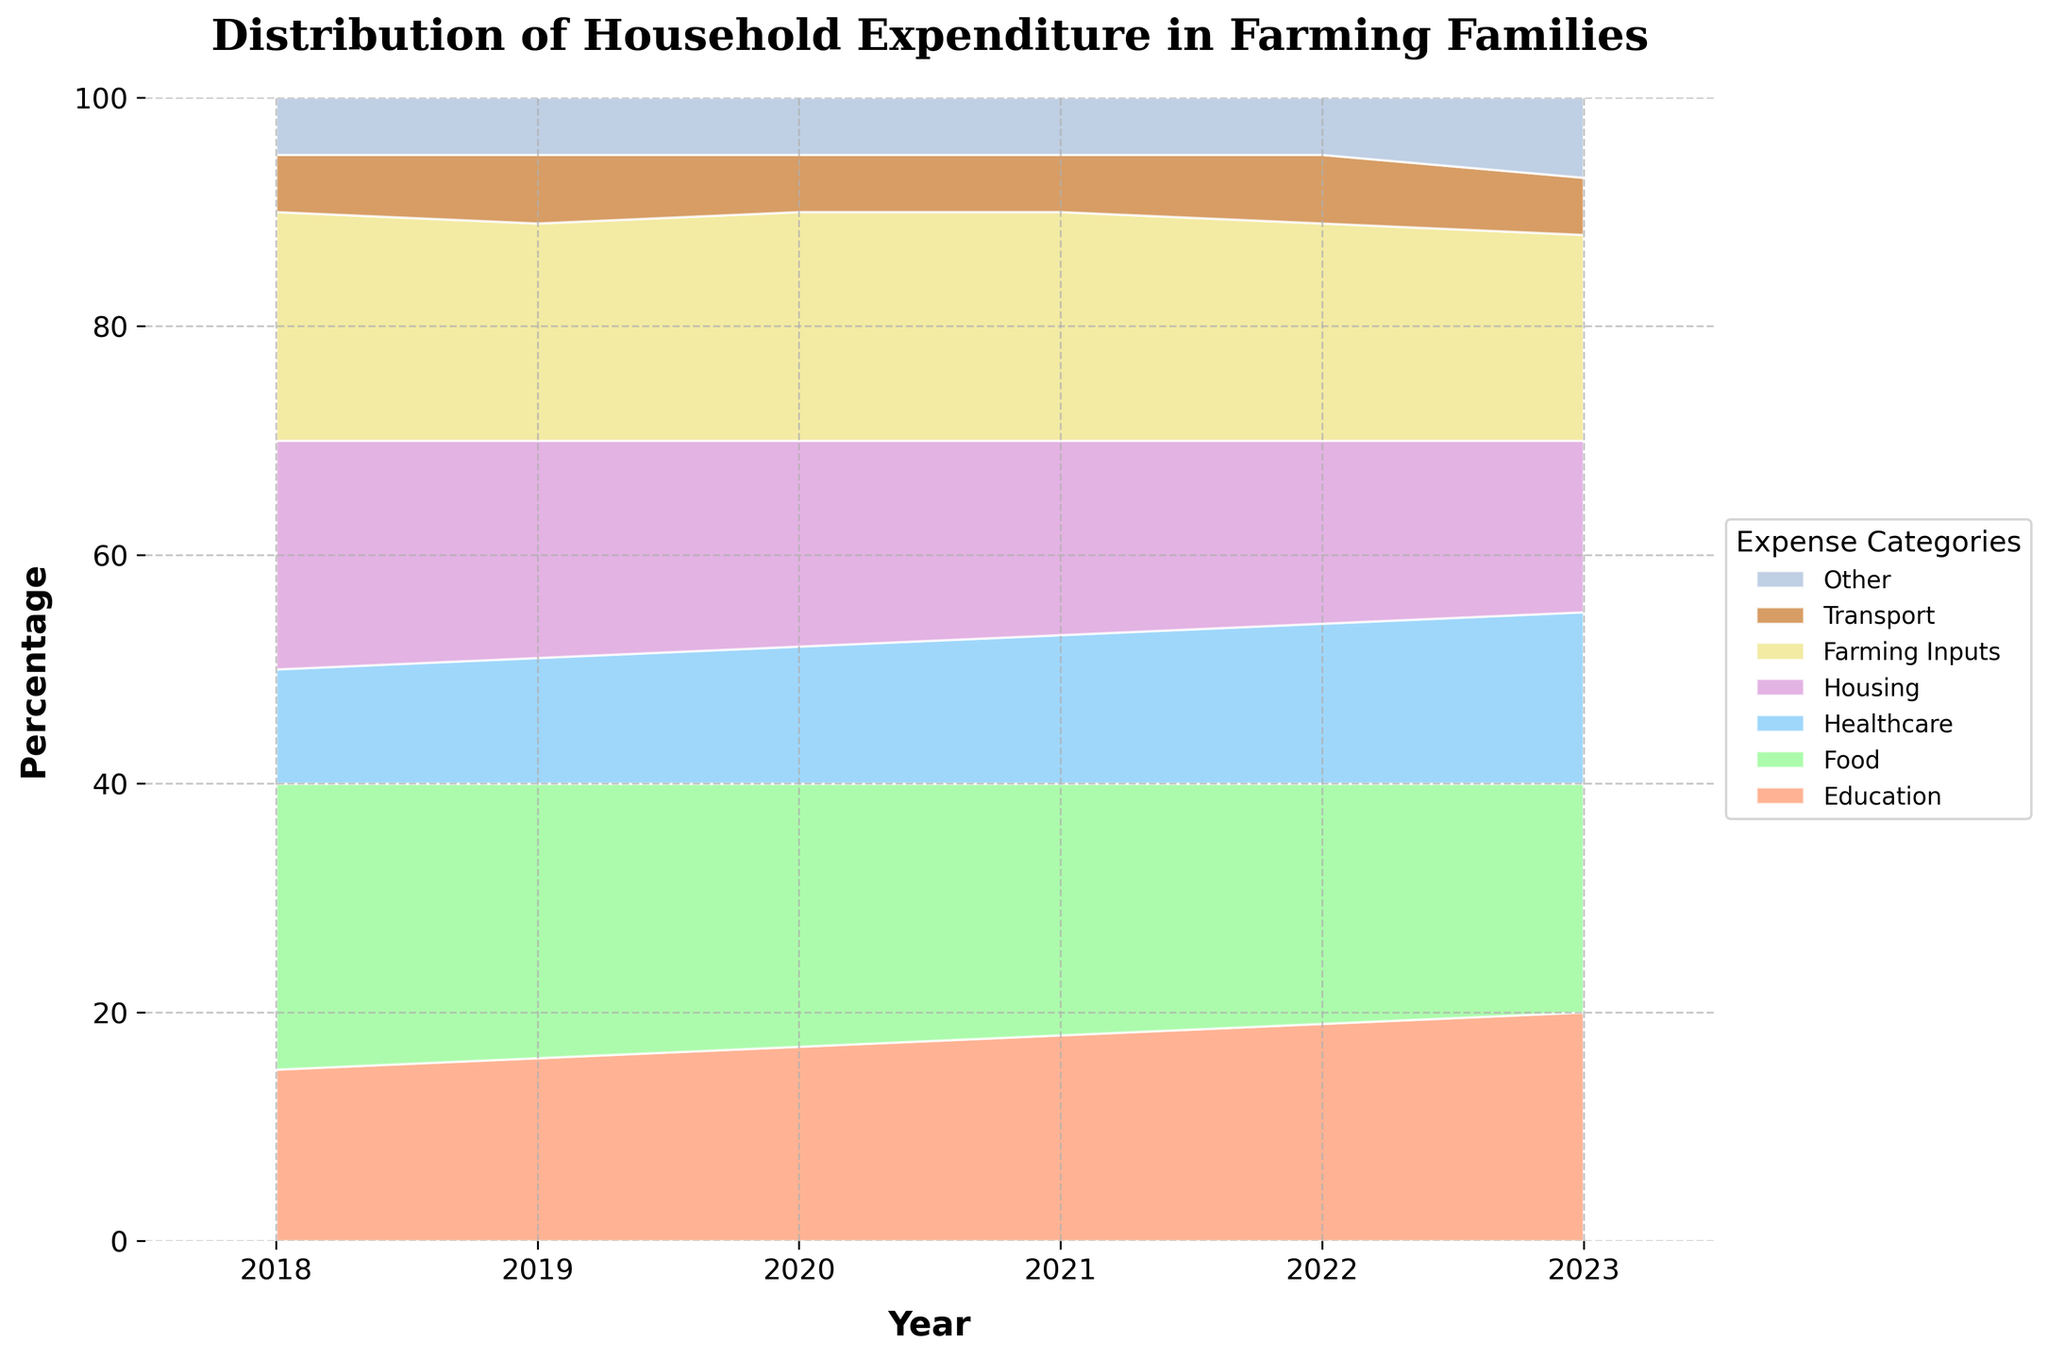What is the title of the chart? The title is displayed at the top of the chart, indicating the main subject or focus of the figure. In this case, it is "Distribution of Household Expenditure in Farming Families".
Answer: Distribution of Household Expenditure in Farming Families Which year shows the highest percentage of expenditure on children's education? Look at the area representing education and its relative size across the years. The year with the largest area is where the percentage is highest.
Answer: 2023 How did the percentage of expenditure on farming inputs change from 2018 to 2023? Observe the area dedicated to 'Farming Inputs' from 2018 to 2023. Compare its size in both years to determine the change. In 2018, it is 20%, and in 2023, it is 18%, showing a decrease.
Answer: Decreased Which two expense categories remained constant in percentage from 2019 to 2021? Find categories whose areas do not visually change in percentage over the years 2019, 2020, and 2021. Both 'Transport' and 'Other' expenses remained at 5% during these years.
Answer: Transport and Other Which expenditure category saw a rise in percentage every year from 2018 to 2023? Look for the category whose area consistently increases each year. The 'Education' expense grows steadily from 15% in 2018 to 20% in 2023.
Answer: Education In which year was the combined expenditure on housing and healthcare highest? Sum the percentages of 'Housing' and 'Healthcare' for each year and find the year with the highest combined total. The data shows 30% in 2018, and 2023, confirming 2018 having the highest combined expenditure of 30%.
Answer: 2018 What is the percentage difference in expenditure on healthcare between 2018 and 2023? Subtract the percentage of healthcare in 2018 (10%) from that in 2023 (15%). This provides the percentage increase over the period.
Answer: 5% Which category had the smallest percentage share of expenditure in 2023, and what was its value? Identify the expense category with the smallest area in 2023. The 'Transport' category is the smallest with 5%.
Answer: Transport, 5% In 2020, what percentage of the household expenditure was allocated to non-education expenses? Subtract the education expenditure percentage for 2020 (17%) from 100%. This results in the percentage allocated to all other expenses.
Answer: 83% Have the education expenses exceeded healthcare expenses in every year? For each year, compare the education percentage to the healthcare percentage to confirm if education was consistently higher. In all years, education expenses were higher than healthcare.
Answer: Yes 